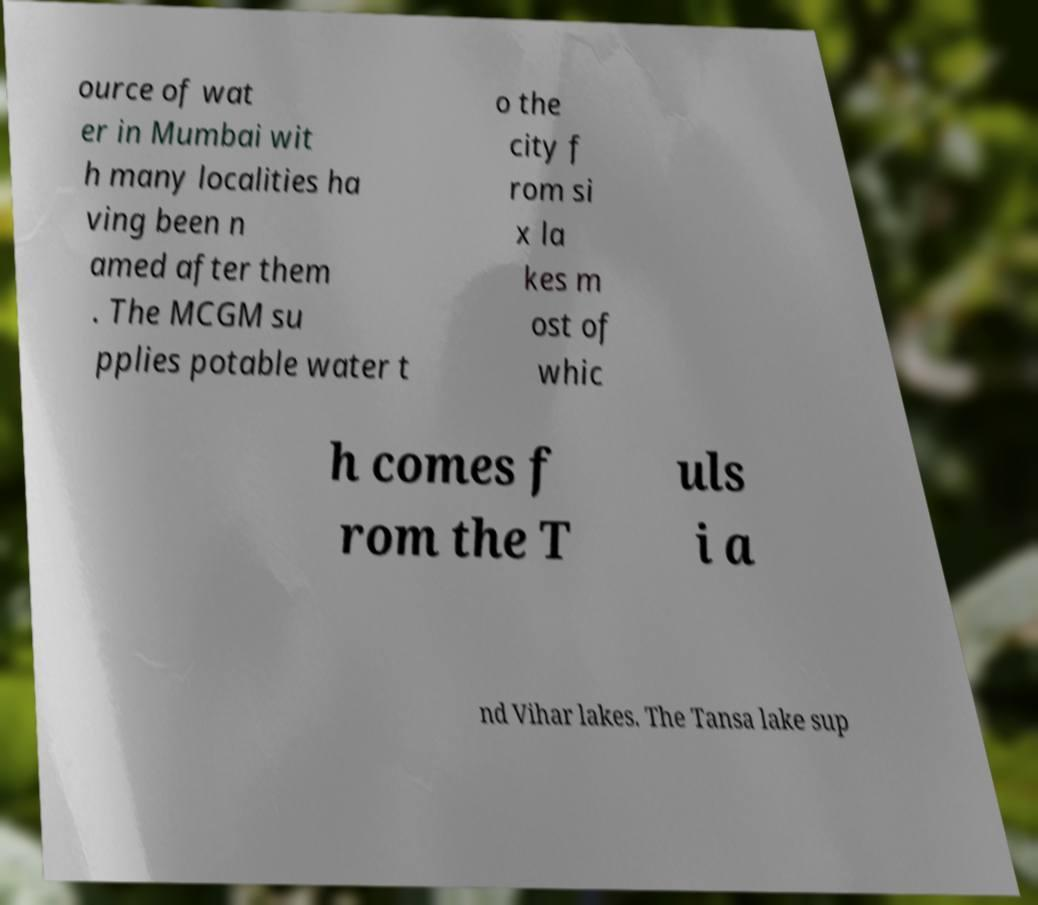For documentation purposes, I need the text within this image transcribed. Could you provide that? ource of wat er in Mumbai wit h many localities ha ving been n amed after them . The MCGM su pplies potable water t o the city f rom si x la kes m ost of whic h comes f rom the T uls i a nd Vihar lakes. The Tansa lake sup 